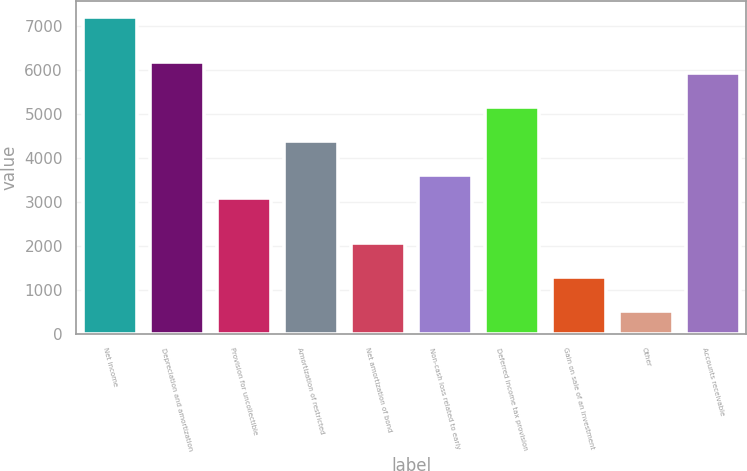Convert chart to OTSL. <chart><loc_0><loc_0><loc_500><loc_500><bar_chart><fcel>Net income<fcel>Depreciation and amortization<fcel>Provision for uncollectible<fcel>Amortization of restricted<fcel>Net amortization of bond<fcel>Non-cash loss related to early<fcel>Deferred income tax provision<fcel>Gain on sale of an investment<fcel>Other<fcel>Accounts receivable<nl><fcel>7208<fcel>6178.4<fcel>3089.6<fcel>4376.6<fcel>2060<fcel>3604.4<fcel>5148.8<fcel>1287.8<fcel>515.6<fcel>5921<nl></chart> 